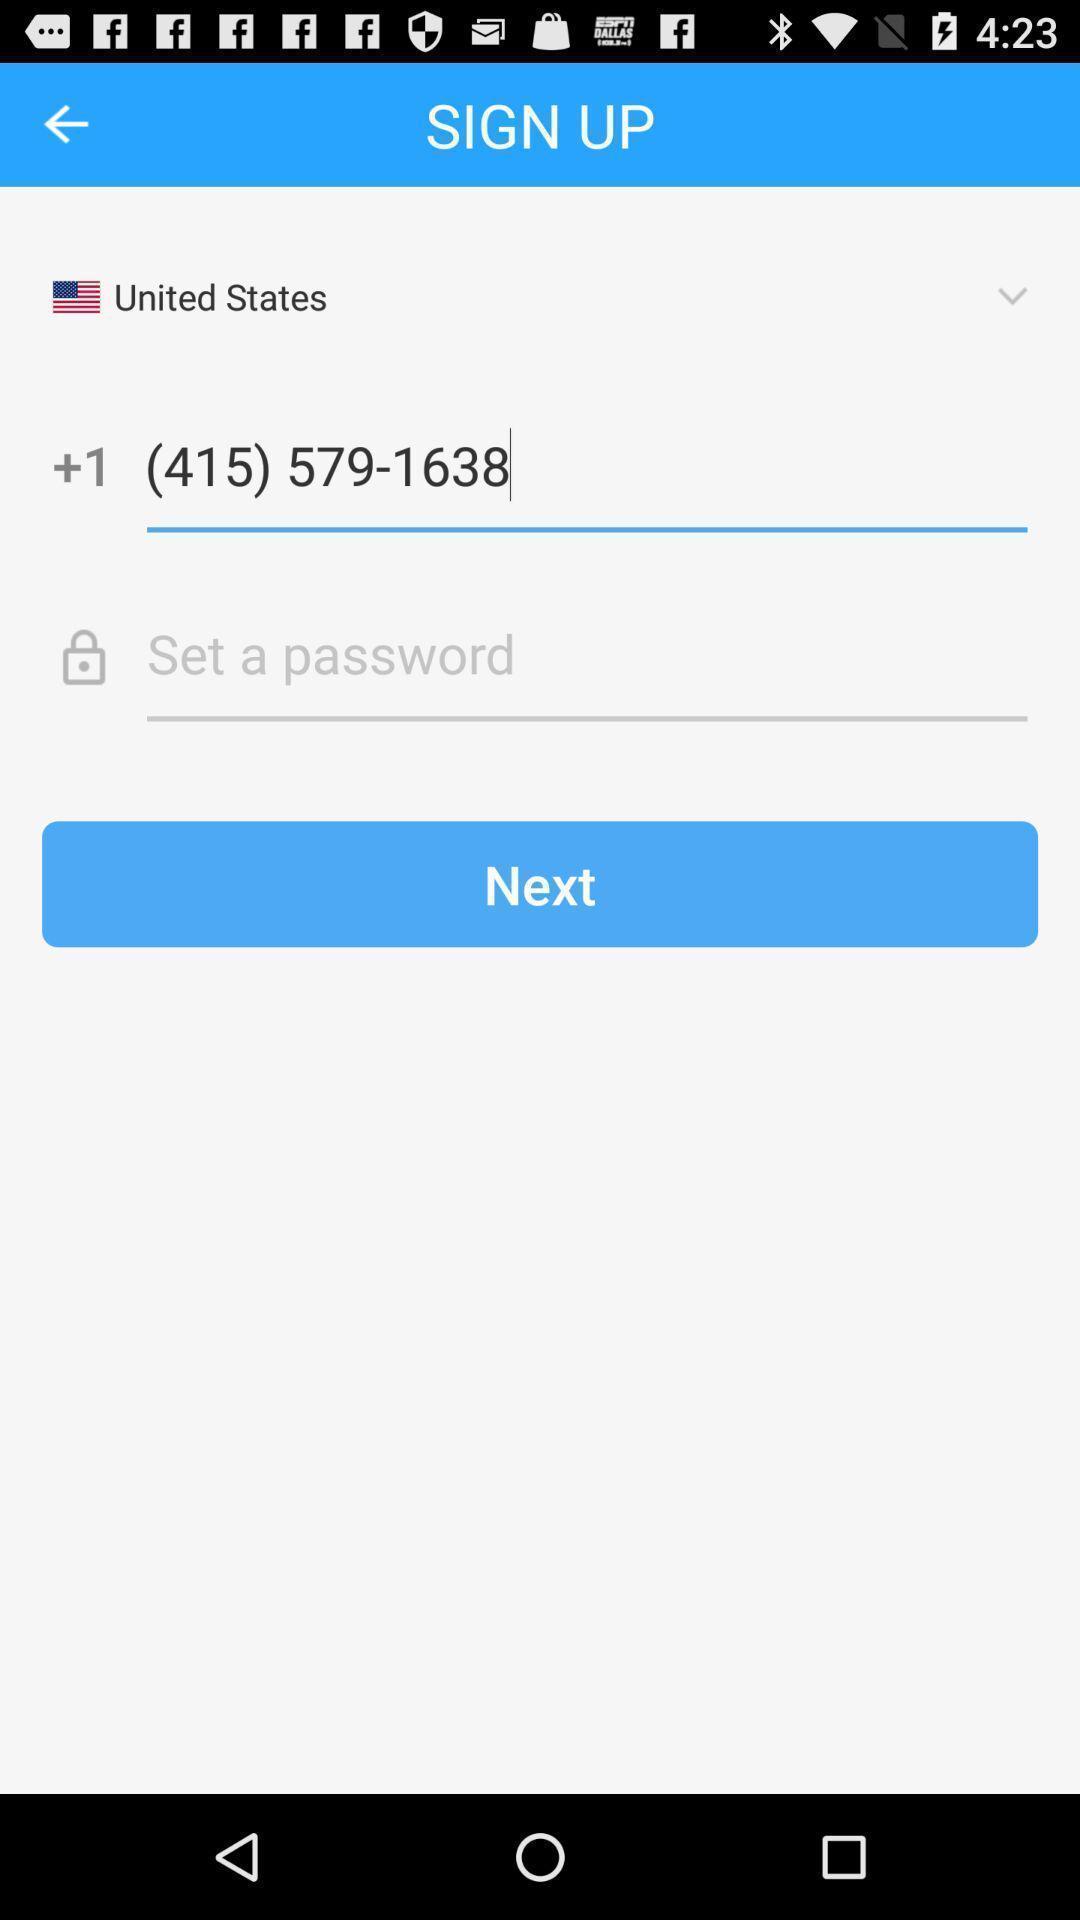Provide a textual representation of this image. Sign up page. 